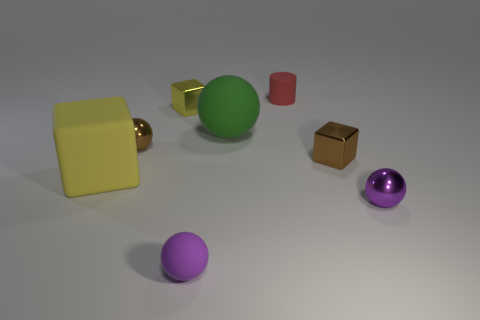Subtract 1 spheres. How many spheres are left? 3 Add 2 large yellow matte things. How many objects exist? 10 Subtract all blocks. How many objects are left? 5 Add 5 purple spheres. How many purple spheres exist? 7 Subtract 0 purple blocks. How many objects are left? 8 Subtract all tiny balls. Subtract all small purple metal objects. How many objects are left? 4 Add 2 yellow shiny objects. How many yellow shiny objects are left? 3 